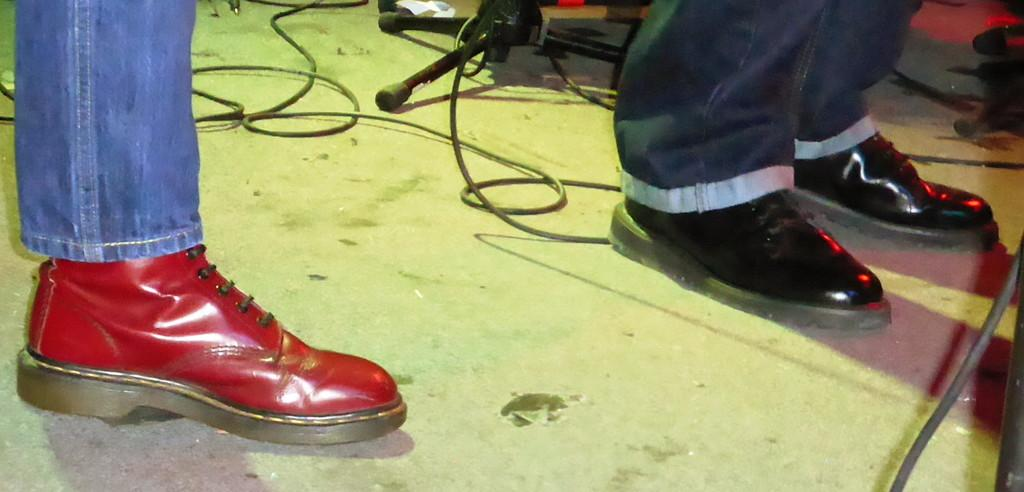What body parts are visible in the image? There are legs of persons visible in the image. Where are the legs located? The legs are on the floor. What are the legs wearing? There are shoes on the legs. What else can be seen on the floor in the image? Cable wires and a stand are present on the floor. What type of glove is being used by the brothers in the image? There is no glove or reference to brothers present in the image. 